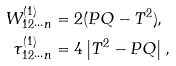<formula> <loc_0><loc_0><loc_500><loc_500>W _ { 1 2 \cdots n } ^ { ( 1 ) } & = 2 ( P Q - T ^ { 2 } ) \text {,} \\ \tau _ { 1 2 \cdots n } ^ { ( 1 ) } & = 4 \left | T ^ { 2 } - P Q \right | ,</formula> 